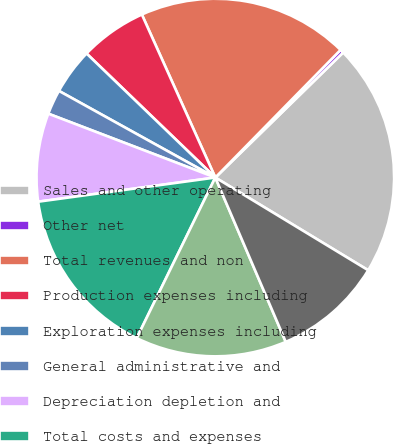Convert chart. <chart><loc_0><loc_0><loc_500><loc_500><pie_chart><fcel>Sales and other operating<fcel>Other net<fcel>Total revenues and non<fcel>Production expenses including<fcel>Exploration expenses including<fcel>General administrative and<fcel>Depreciation depletion and<fcel>Total costs and expenses<fcel>Results of operations from<fcel>Provision for income taxes<nl><fcel>21.0%<fcel>0.33%<fcel>19.09%<fcel>6.06%<fcel>4.15%<fcel>2.24%<fcel>7.97%<fcel>15.6%<fcel>13.69%<fcel>9.88%<nl></chart> 